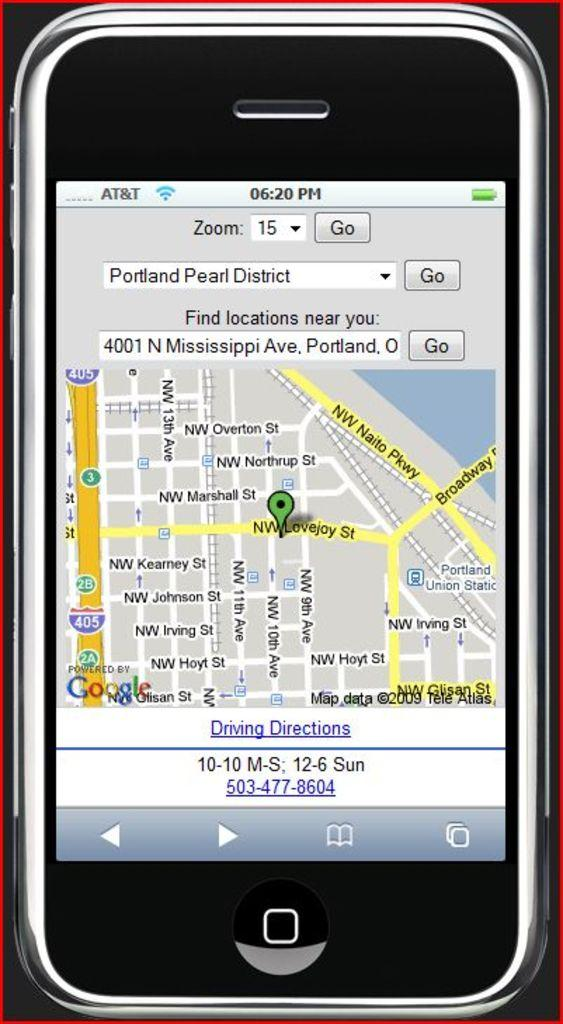<image>
Render a clear and concise summary of the photo. A phone is display the map location of the Portland Pearl District. 